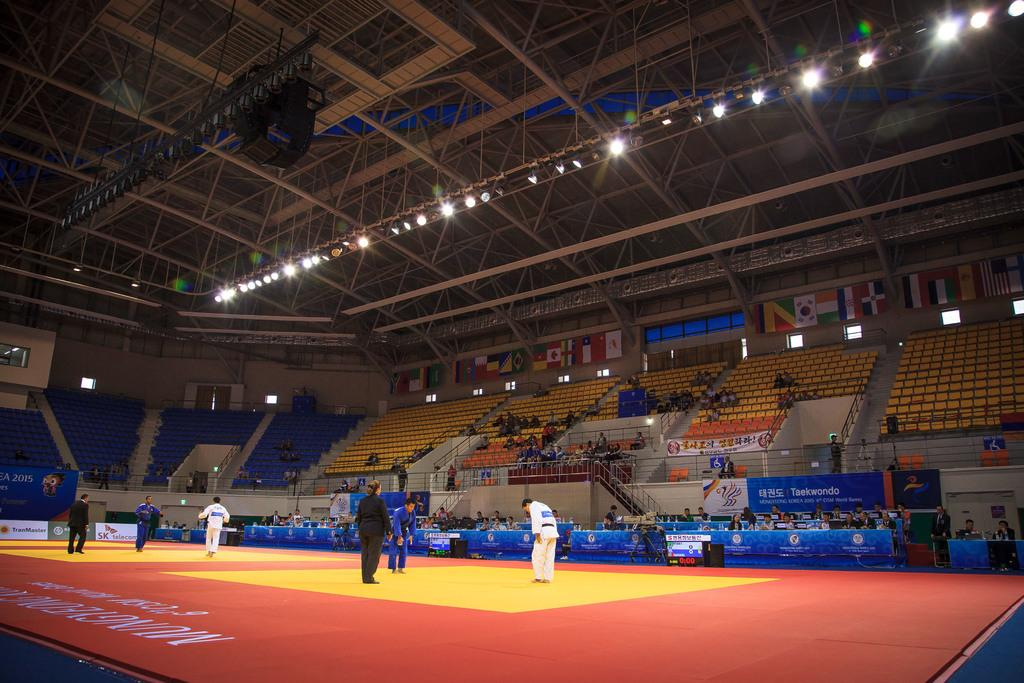Provide a one-sentence caption for the provided image. A martial arts match is underway in a stadium sponsored by SK telecom. 